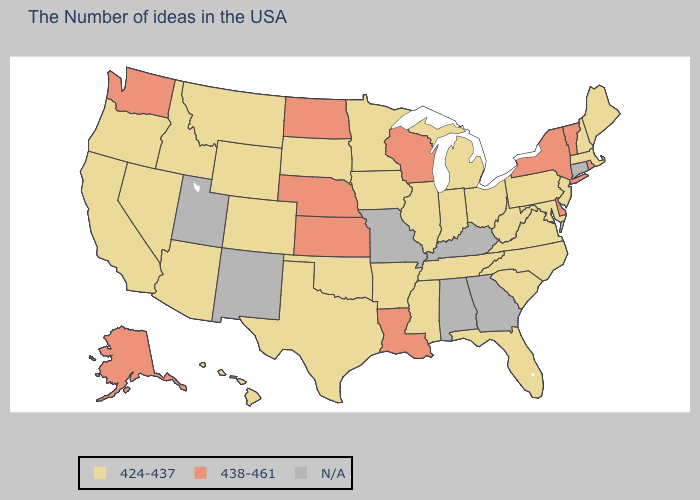What is the highest value in states that border Oregon?
Write a very short answer. 438-461. Name the states that have a value in the range 438-461?
Be succinct. Rhode Island, Vermont, New York, Delaware, Wisconsin, Louisiana, Kansas, Nebraska, North Dakota, Washington, Alaska. Is the legend a continuous bar?
Keep it brief. No. What is the value of Pennsylvania?
Concise answer only. 424-437. Does North Dakota have the lowest value in the USA?
Be succinct. No. Name the states that have a value in the range 438-461?
Concise answer only. Rhode Island, Vermont, New York, Delaware, Wisconsin, Louisiana, Kansas, Nebraska, North Dakota, Washington, Alaska. Which states have the lowest value in the South?
Give a very brief answer. Maryland, Virginia, North Carolina, South Carolina, West Virginia, Florida, Tennessee, Mississippi, Arkansas, Oklahoma, Texas. What is the value of Kentucky?
Short answer required. N/A. Does Massachusetts have the lowest value in the USA?
Be succinct. Yes. What is the value of Texas?
Answer briefly. 424-437. What is the highest value in the West ?
Write a very short answer. 438-461. What is the value of Hawaii?
Keep it brief. 424-437. Name the states that have a value in the range 424-437?
Quick response, please. Maine, Massachusetts, New Hampshire, New Jersey, Maryland, Pennsylvania, Virginia, North Carolina, South Carolina, West Virginia, Ohio, Florida, Michigan, Indiana, Tennessee, Illinois, Mississippi, Arkansas, Minnesota, Iowa, Oklahoma, Texas, South Dakota, Wyoming, Colorado, Montana, Arizona, Idaho, Nevada, California, Oregon, Hawaii. What is the value of New Hampshire?
Answer briefly. 424-437. What is the value of Arkansas?
Keep it brief. 424-437. 